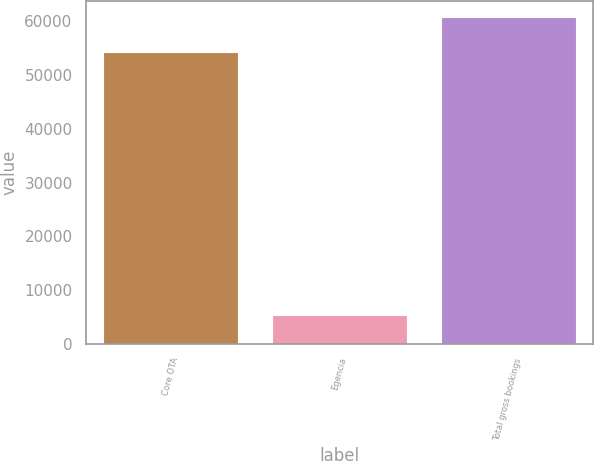Convert chart. <chart><loc_0><loc_0><loc_500><loc_500><bar_chart><fcel>Core OTA<fcel>Egencia<fcel>Total gross bookings<nl><fcel>54252<fcel>5427<fcel>60830<nl></chart> 